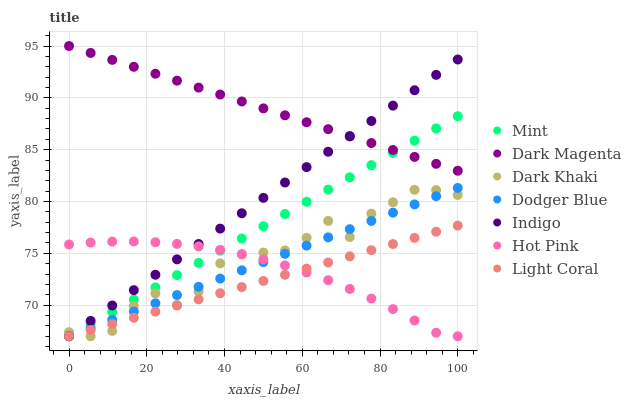Does Light Coral have the minimum area under the curve?
Answer yes or no. Yes. Does Dark Magenta have the maximum area under the curve?
Answer yes or no. Yes. Does Indigo have the minimum area under the curve?
Answer yes or no. No. Does Indigo have the maximum area under the curve?
Answer yes or no. No. Is Mint the smoothest?
Answer yes or no. Yes. Is Dark Khaki the roughest?
Answer yes or no. Yes. Is Indigo the smoothest?
Answer yes or no. No. Is Indigo the roughest?
Answer yes or no. No. Does Light Coral have the lowest value?
Answer yes or no. Yes. Does Dark Magenta have the lowest value?
Answer yes or no. No. Does Dark Magenta have the highest value?
Answer yes or no. Yes. Does Indigo have the highest value?
Answer yes or no. No. Is Light Coral less than Dark Magenta?
Answer yes or no. Yes. Is Dark Magenta greater than Light Coral?
Answer yes or no. Yes. Does Light Coral intersect Dark Khaki?
Answer yes or no. Yes. Is Light Coral less than Dark Khaki?
Answer yes or no. No. Is Light Coral greater than Dark Khaki?
Answer yes or no. No. Does Light Coral intersect Dark Magenta?
Answer yes or no. No. 